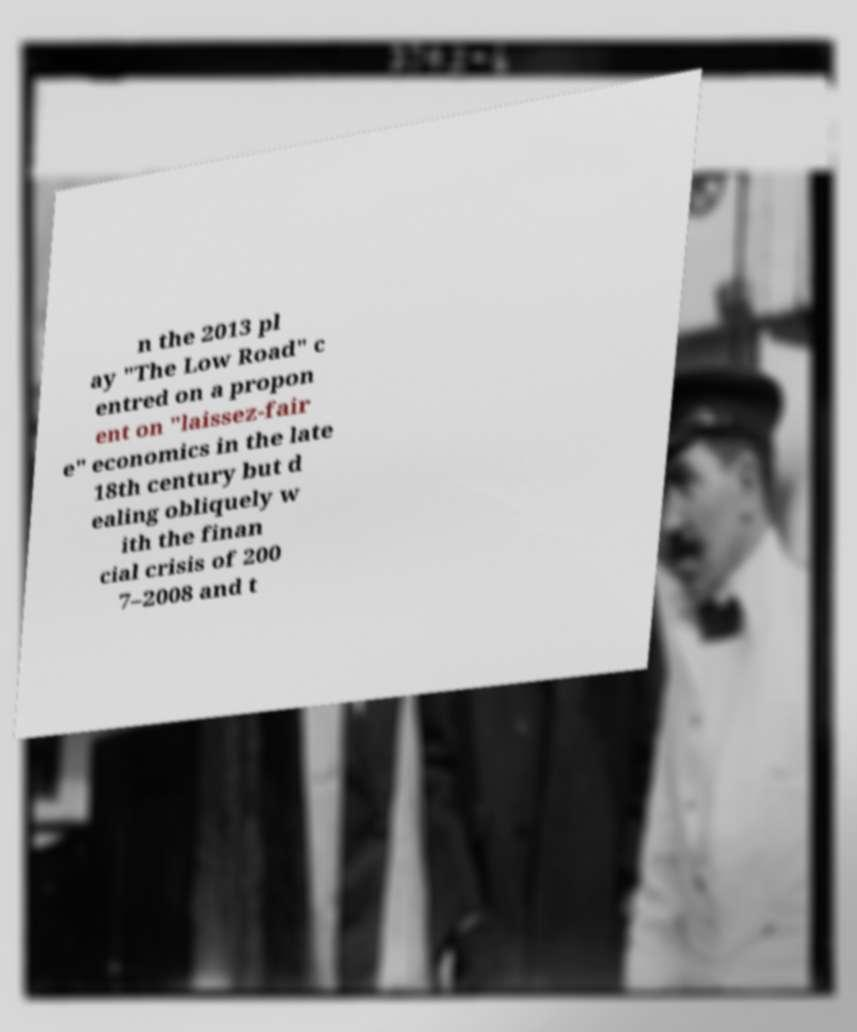For documentation purposes, I need the text within this image transcribed. Could you provide that? n the 2013 pl ay "The Low Road" c entred on a propon ent on "laissez-fair e" economics in the late 18th century but d ealing obliquely w ith the finan cial crisis of 200 7–2008 and t 